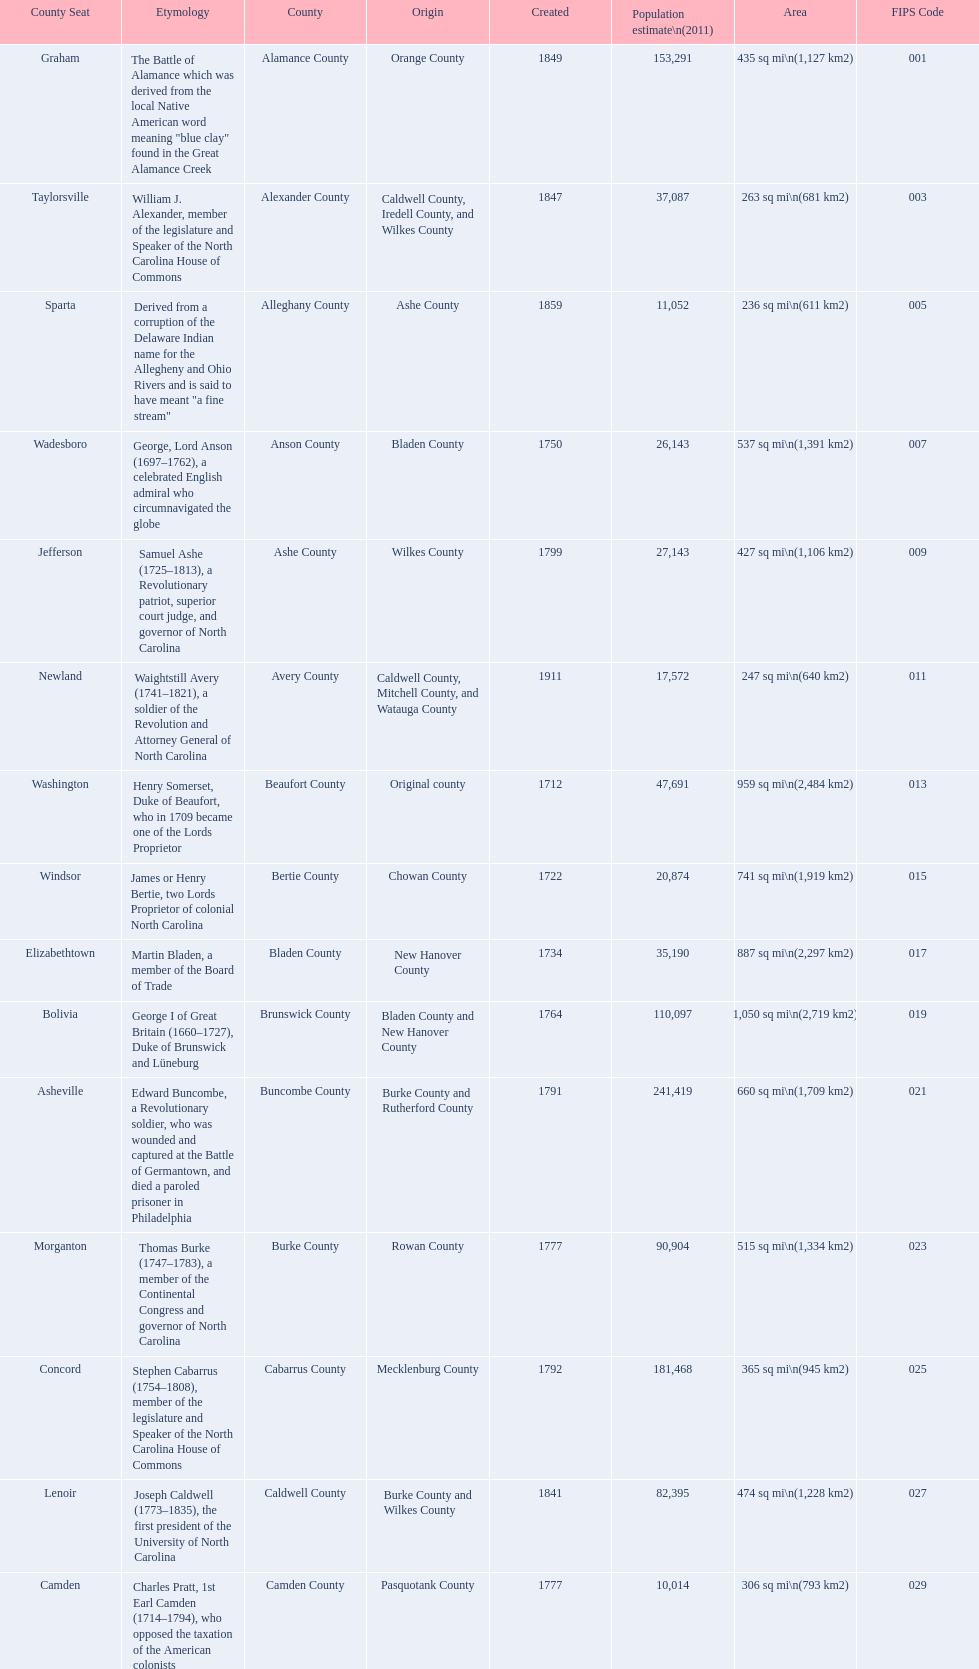What is the total number of counties listed? 100. 